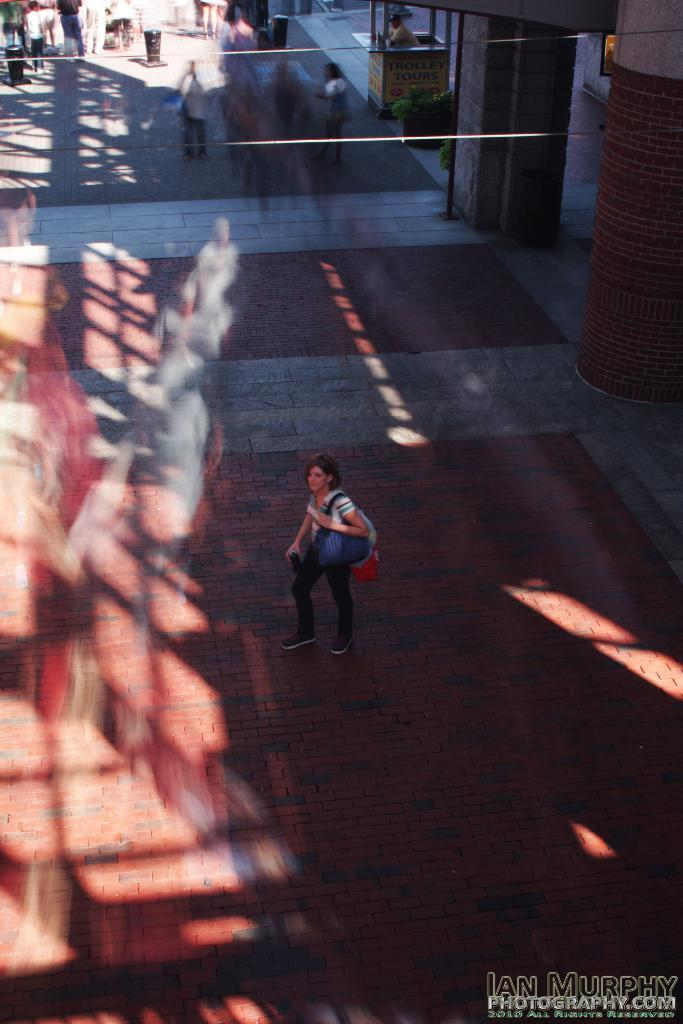What is the person in the image doing? There is a person walking in the image. What color is the person's shirt? The person is wearing a white shirt. What color are the person's pants? The person is wearing black pants. What color is the bag the person is carrying? The person has a blue bag. What can be seen in the background of the image? There are other people walking in the background and a plant. What color is the plant in the background? The plant is green. What type of stage can be seen in the image? There is no stage present in the image. How many horses are visible in the image? There are no horses present in the image. 